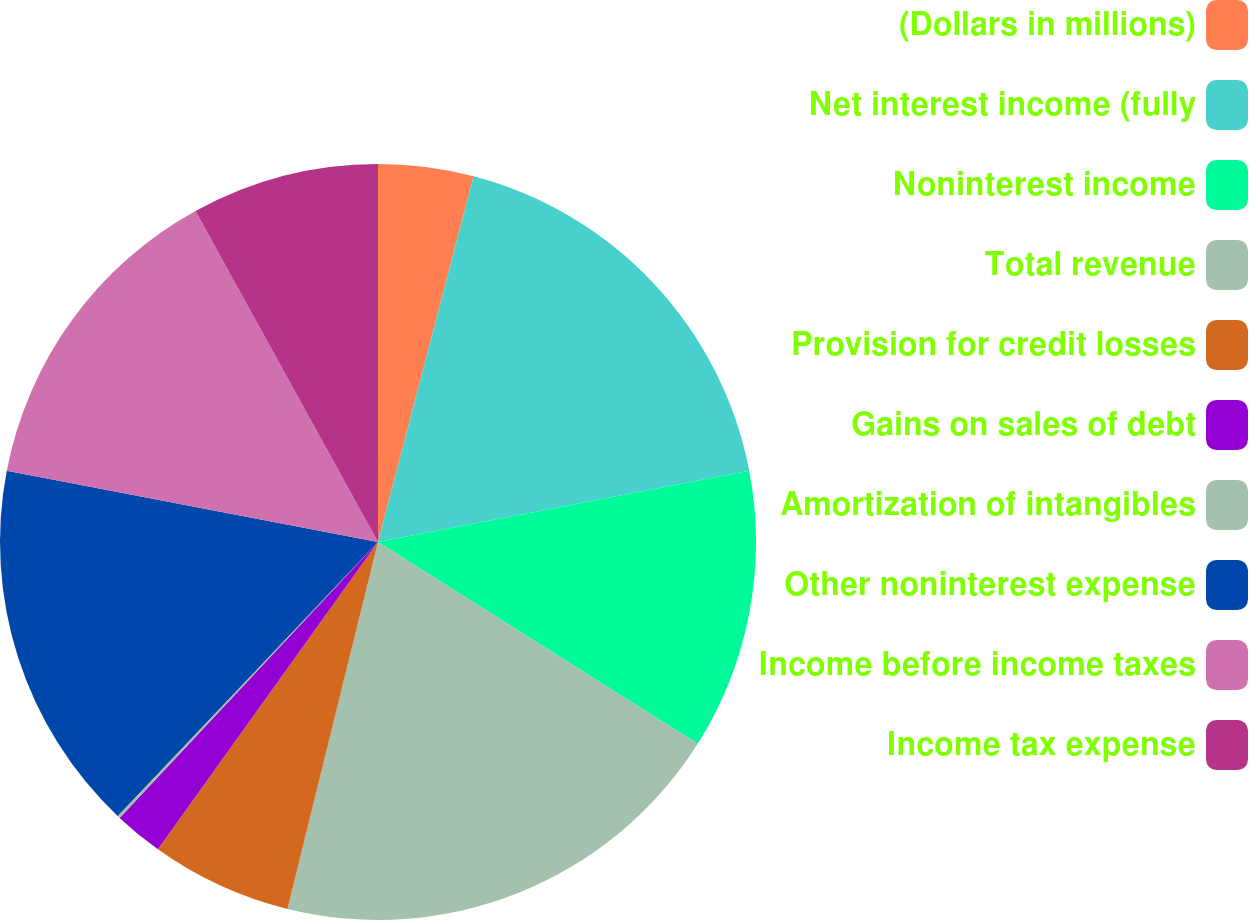Convert chart. <chart><loc_0><loc_0><loc_500><loc_500><pie_chart><fcel>(Dollars in millions)<fcel>Net interest income (fully<fcel>Noninterest income<fcel>Total revenue<fcel>Provision for credit losses<fcel>Gains on sales of debt<fcel>Amortization of intangibles<fcel>Other noninterest expense<fcel>Income before income taxes<fcel>Income tax expense<nl><fcel>4.07%<fcel>17.91%<fcel>11.98%<fcel>19.89%<fcel>6.04%<fcel>2.09%<fcel>0.11%<fcel>15.93%<fcel>13.96%<fcel>8.02%<nl></chart> 